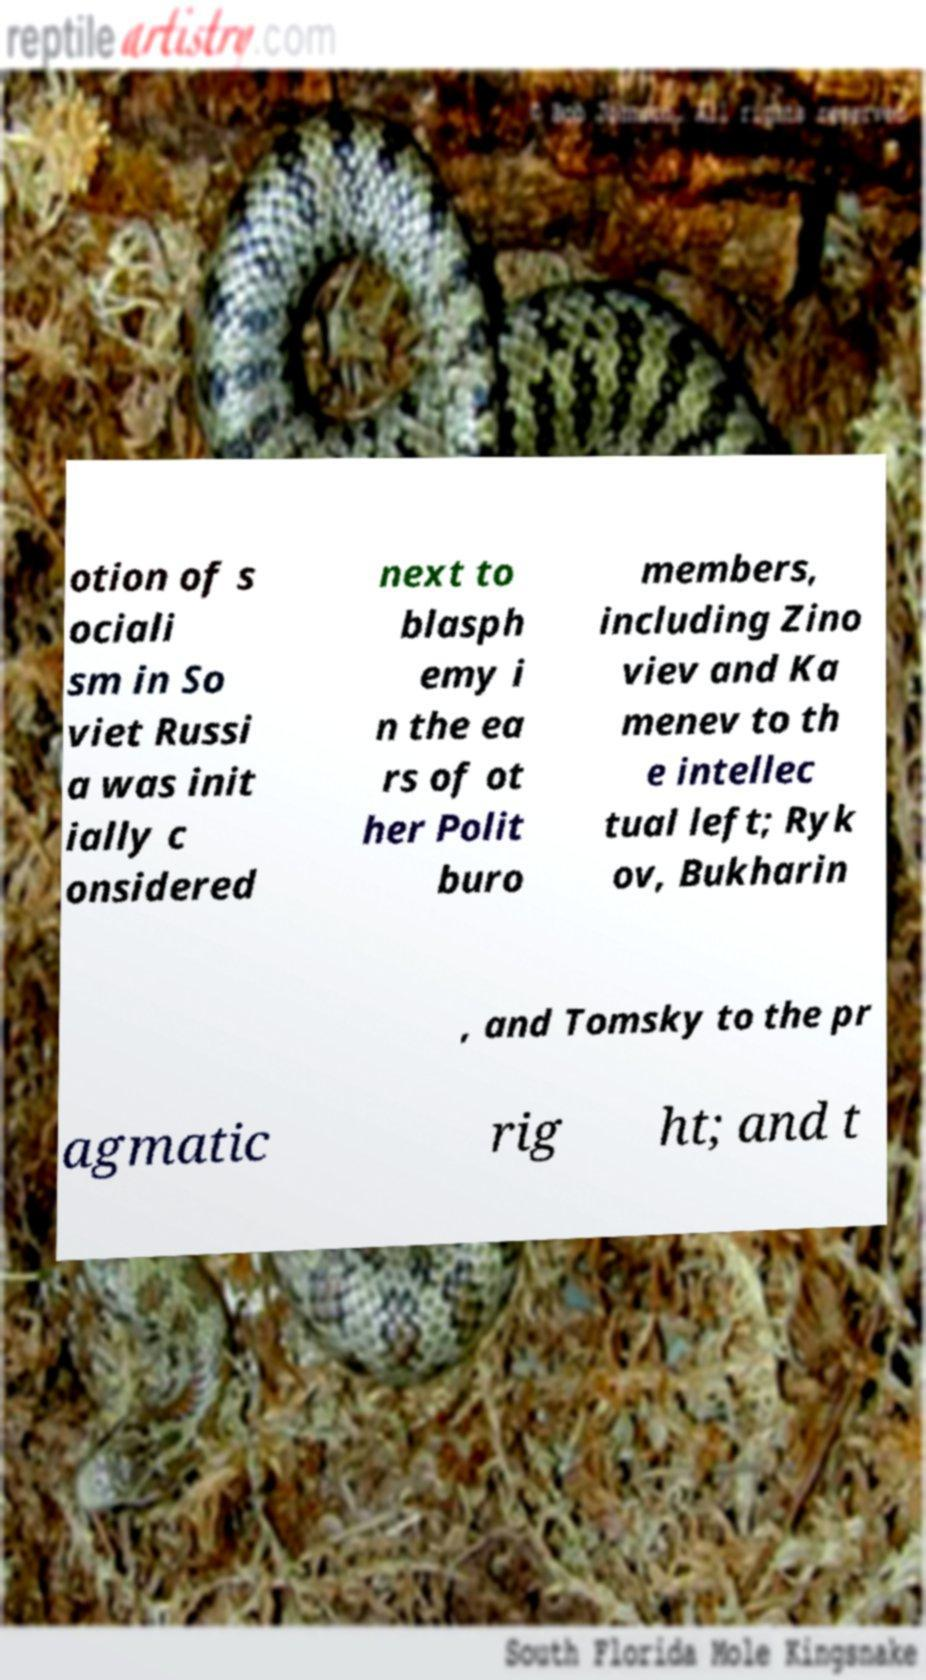What messages or text are displayed in this image? I need them in a readable, typed format. otion of s ociali sm in So viet Russi a was init ially c onsidered next to blasph emy i n the ea rs of ot her Polit buro members, including Zino viev and Ka menev to th e intellec tual left; Ryk ov, Bukharin , and Tomsky to the pr agmatic rig ht; and t 